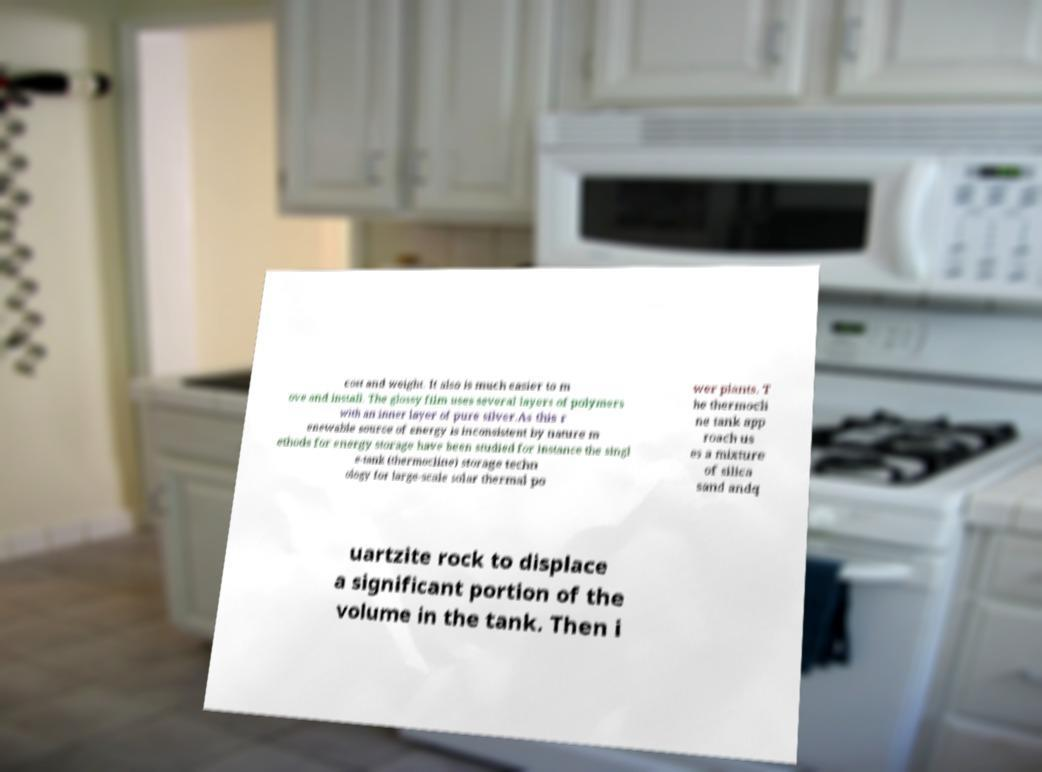Please read and relay the text visible in this image. What does it say? cost and weight. It also is much easier to m ove and install. The glossy film uses several layers of polymers with an inner layer of pure silver.As this r enewable source of energy is inconsistent by nature m ethods for energy storage have been studied for instance the singl e-tank (thermocline) storage techn ology for large-scale solar thermal po wer plants. T he thermocli ne tank app roach us es a mixture of silica sand andq uartzite rock to displace a significant portion of the volume in the tank. Then i 